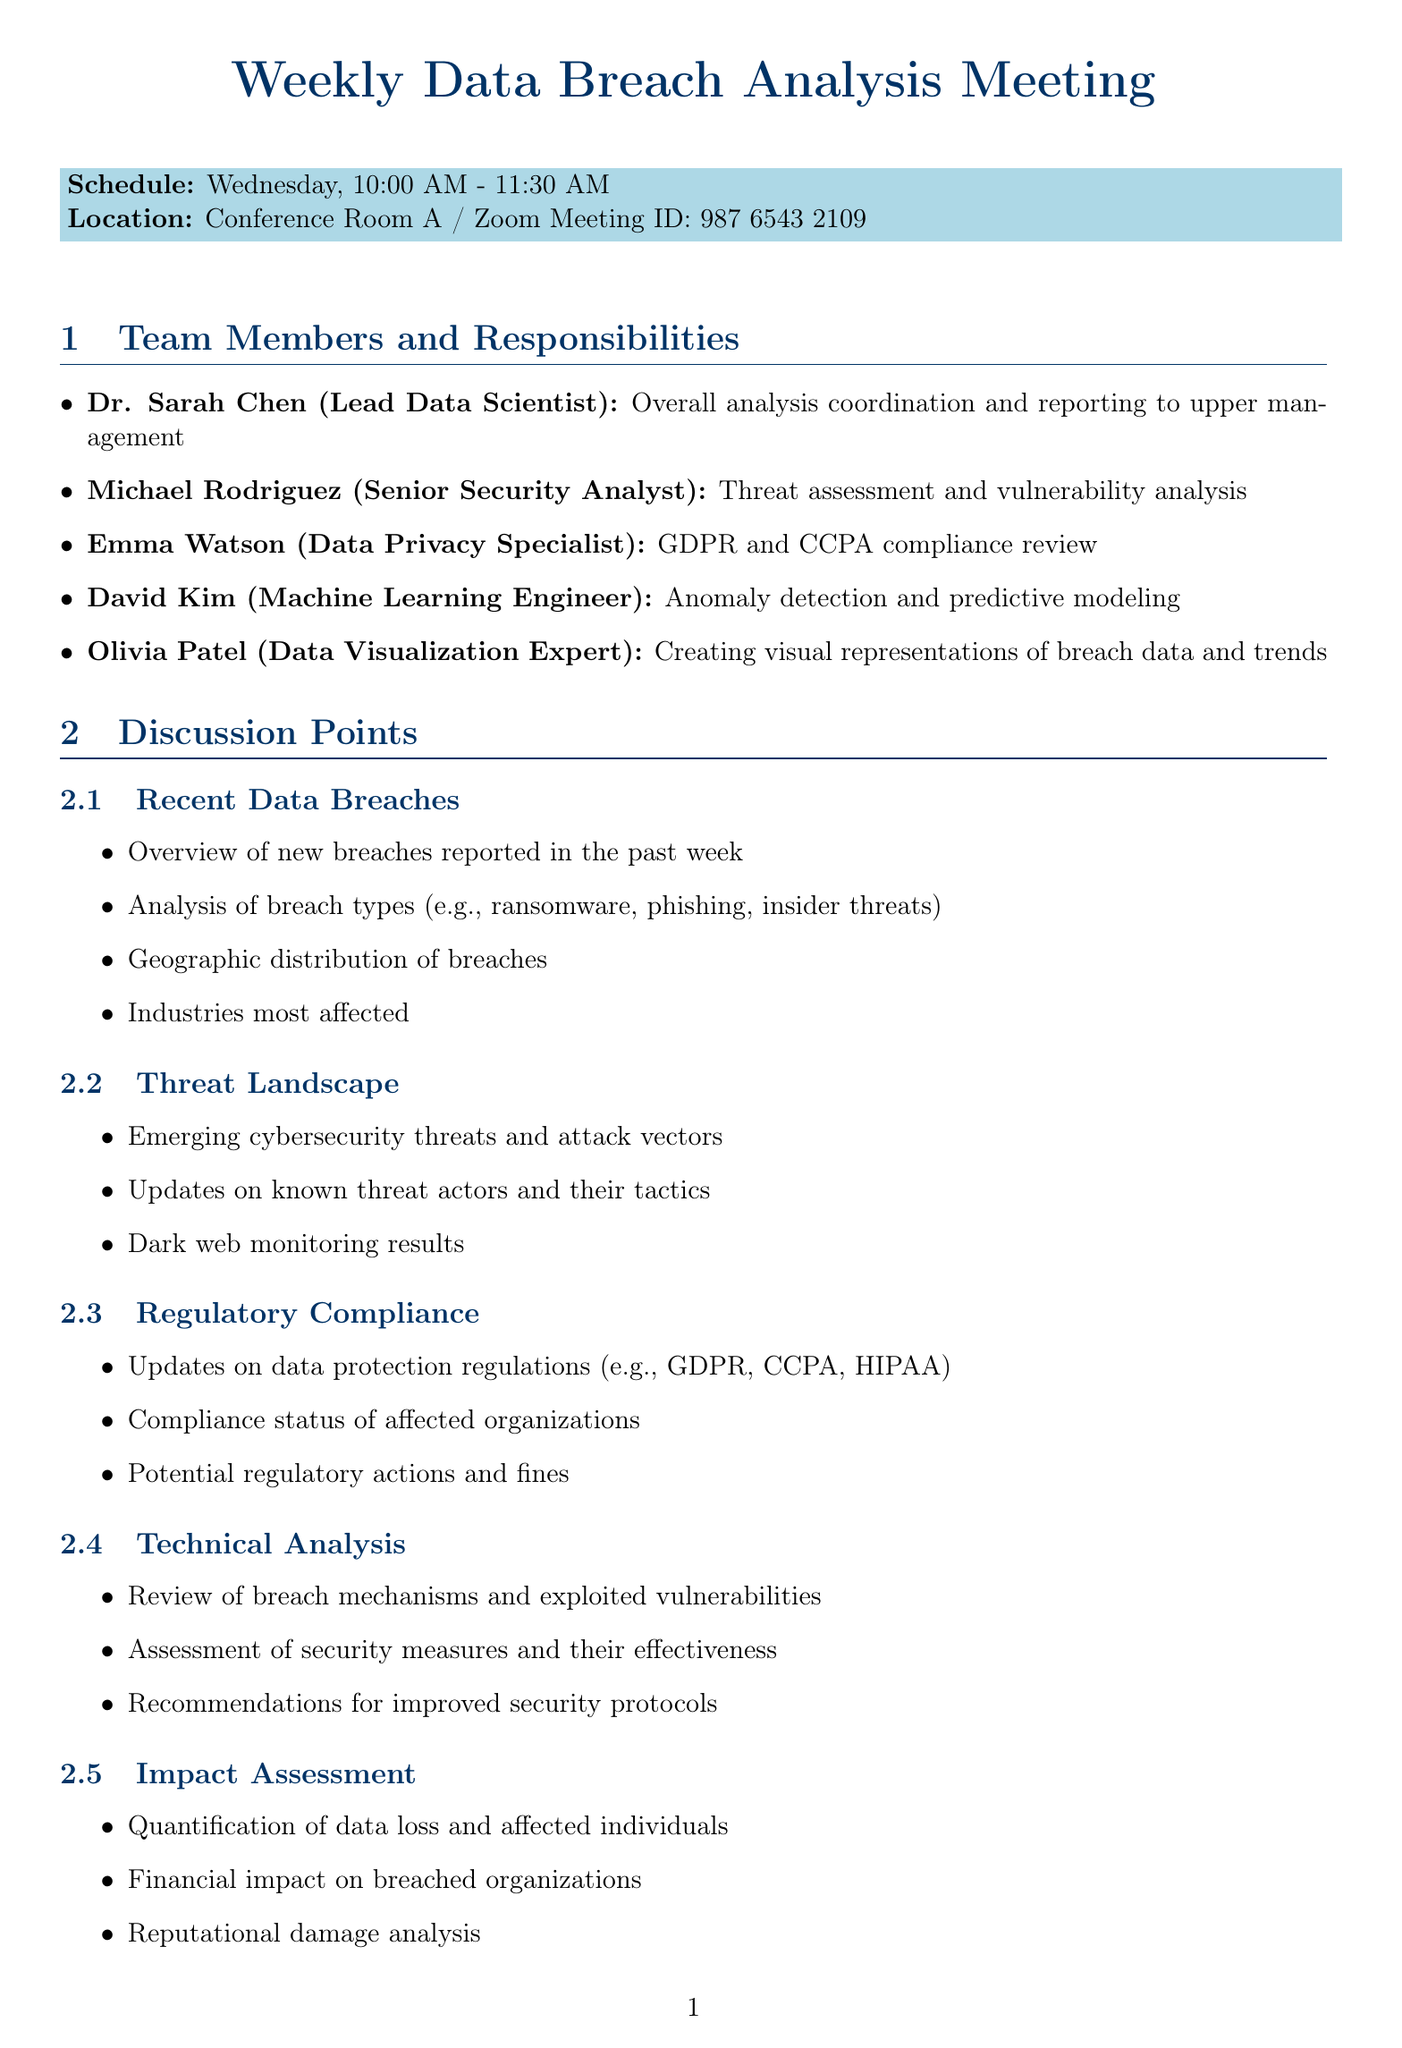What day of the week is the meeting scheduled? The document specifies that the meeting is scheduled for Wednesday.
Answer: Wednesday Who is the Lead Data Scientist? The document lists Dr. Sarah Chen as the Lead Data Scientist.
Answer: Dr. Sarah Chen How many discussion points are listed in the document? The document outlines seven distinct discussion points.
Answer: 7 What is the purpose of the Have I Been Pwned API? The document states that this API is used for checking for compromised accounts.
Answer: Checking for compromised accounts What is one of the subtopics under Recent Data Breaches? The document mentions "Overview of new breaches reported in the past week" as a subtopic.
Answer: Overview of new breaches reported in the past week Who is responsible for threat assessment? According to the document, Michael Rodriguez is responsible for threat assessment.
Answer: Michael Rodriguez What is the time duration of the meeting? The document indicates that the meeting lasts for one and a half hours.
Answer: 10:00 AM - 11:30 AM What is the role of Olivia Patel? The document specifies that Olivia Patel is the Data Visualization Expert.
Answer: Data Visualization Expert What is the involvement of Jennifer Lee? The document states that she provides a monthly briefing on high-impact breaches.
Answer: Monthly briefing on high-impact breaches 